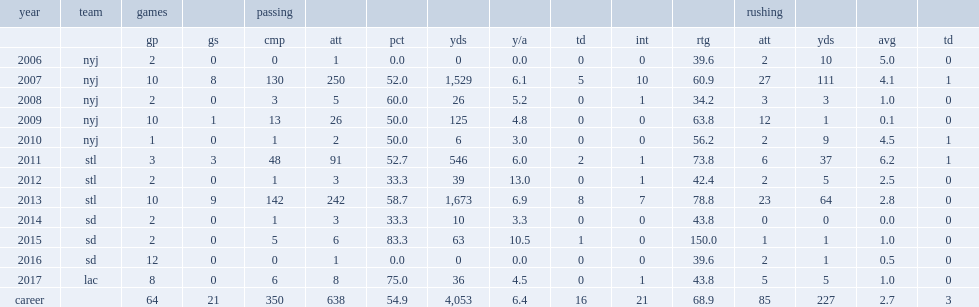How many passing yards did kellen clemens get in 2007? 1529.0. 